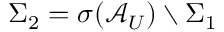<formula> <loc_0><loc_0><loc_500><loc_500>\Sigma _ { 2 } = \sigma ( \mathcal { A } _ { U } ) \ \Sigma _ { 1 }</formula> 